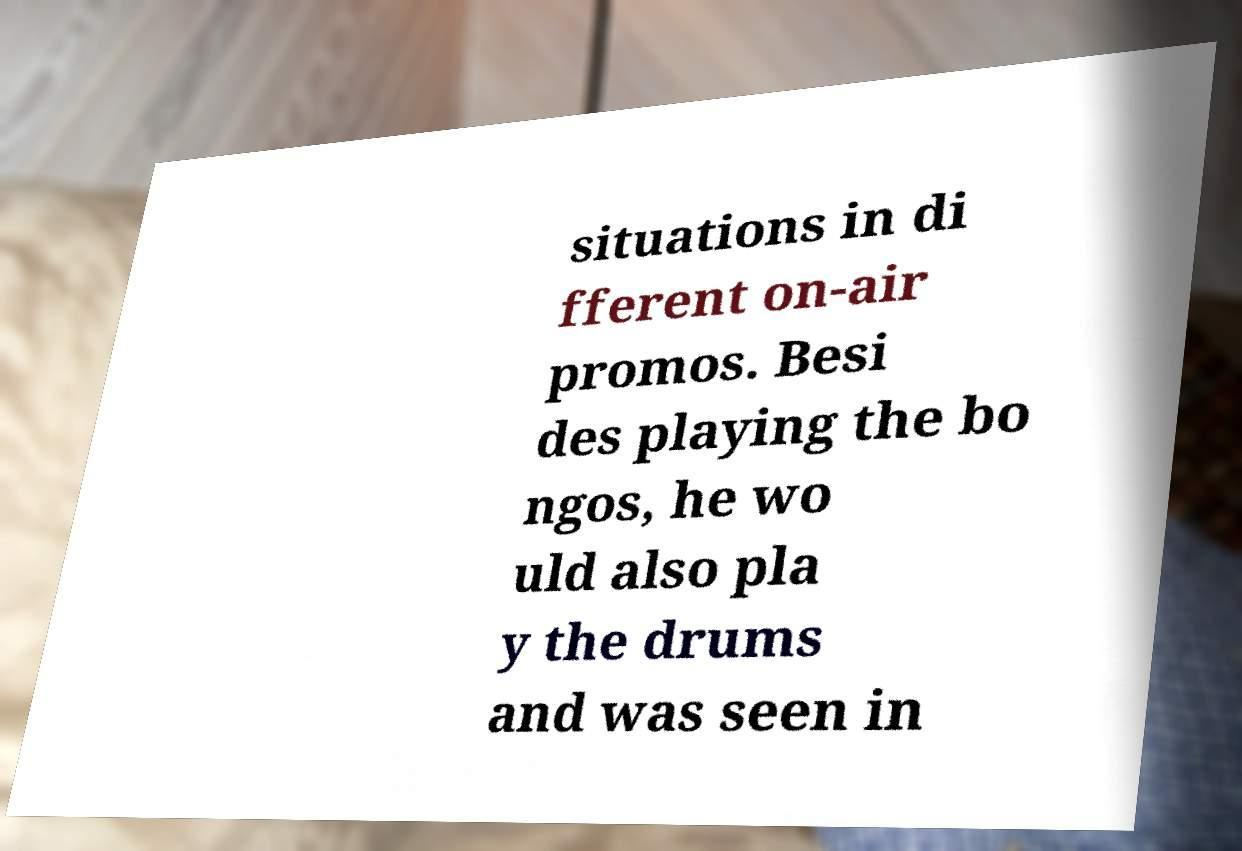What messages or text are displayed in this image? I need them in a readable, typed format. situations in di fferent on-air promos. Besi des playing the bo ngos, he wo uld also pla y the drums and was seen in 